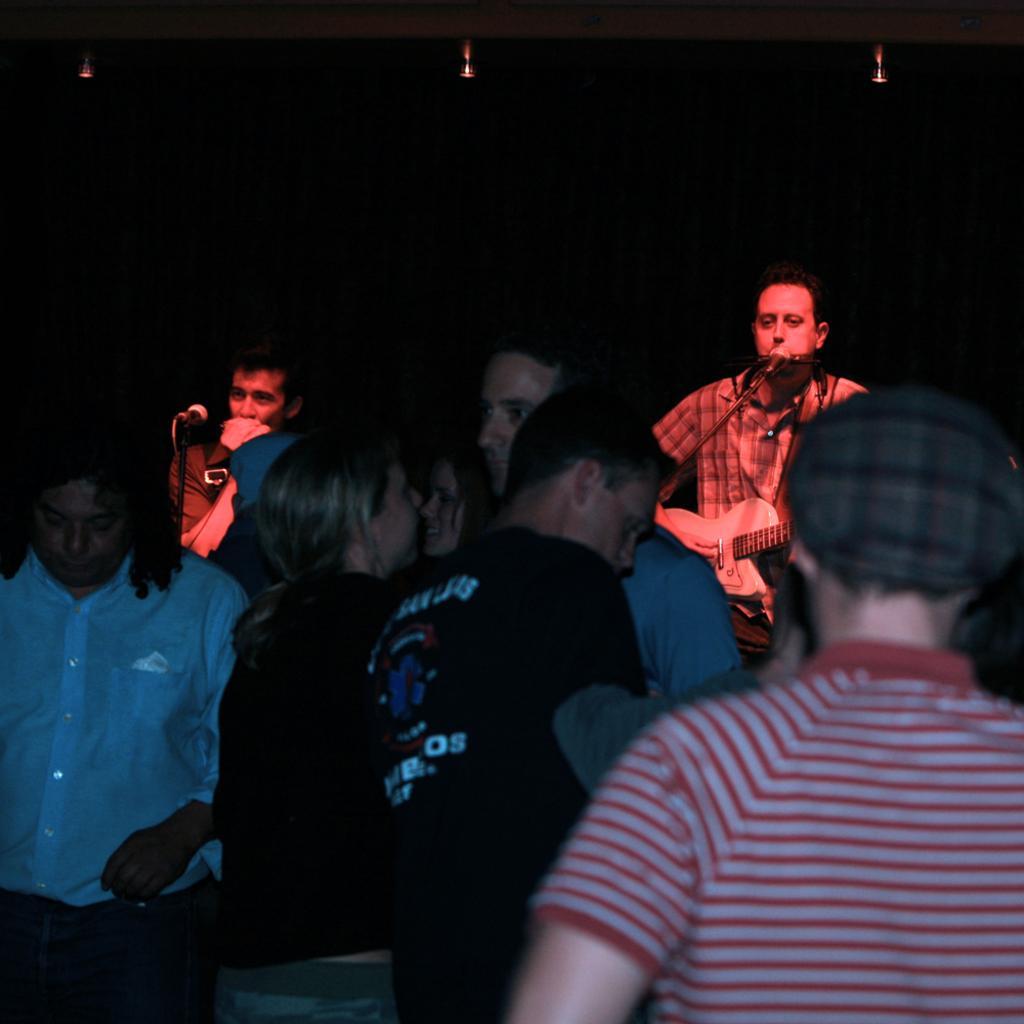Please provide a concise description of this image. There are so much crowd standing and listening to man singing on a microphone and playing guitar. 